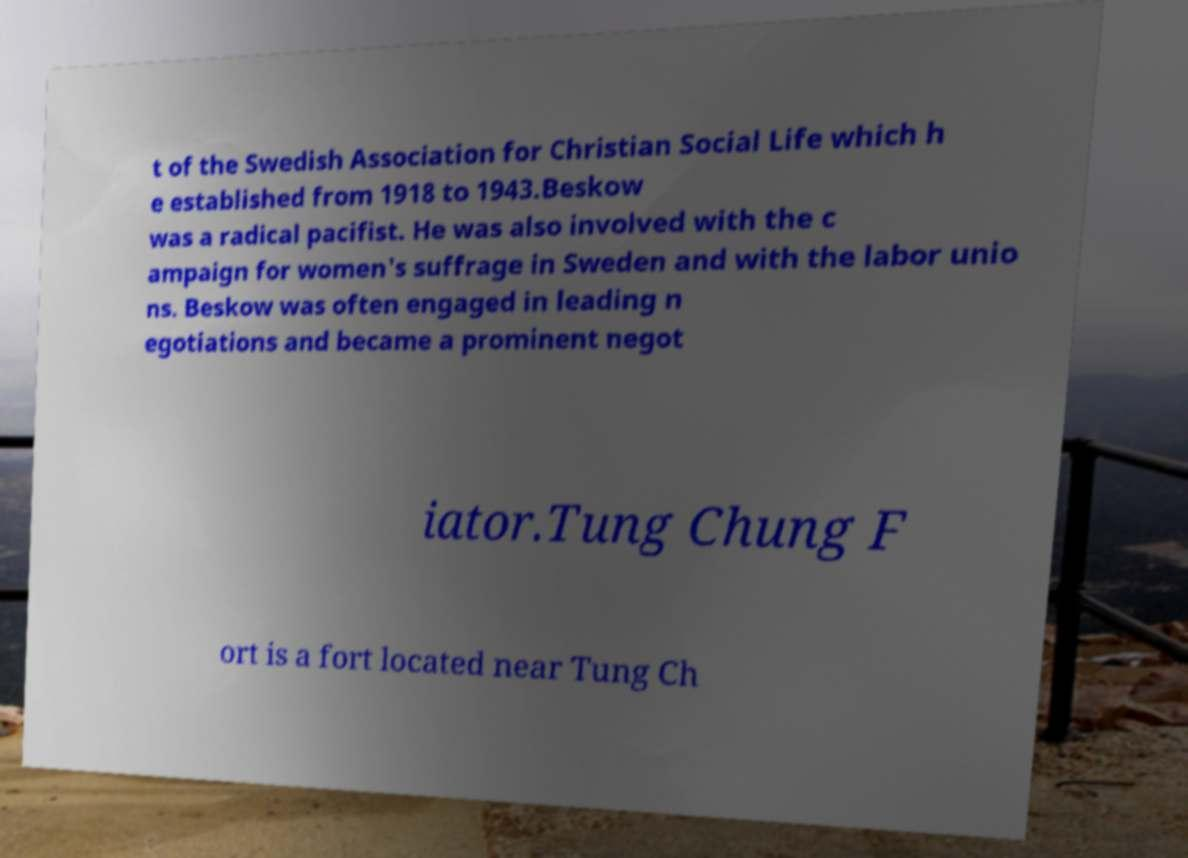Please identify and transcribe the text found in this image. t of the Swedish Association for Christian Social Life which h e established from 1918 to 1943.Beskow was a radical pacifist. He was also involved with the c ampaign for women's suffrage in Sweden and with the labor unio ns. Beskow was often engaged in leading n egotiations and became a prominent negot iator.Tung Chung F ort is a fort located near Tung Ch 